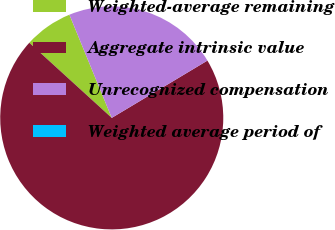Convert chart. <chart><loc_0><loc_0><loc_500><loc_500><pie_chart><fcel>Weighted-average remaining<fcel>Aggregate intrinsic value<fcel>Unrecognized compensation<fcel>Weighted average period of<nl><fcel>7.04%<fcel>70.35%<fcel>22.61%<fcel>0.0%<nl></chart> 